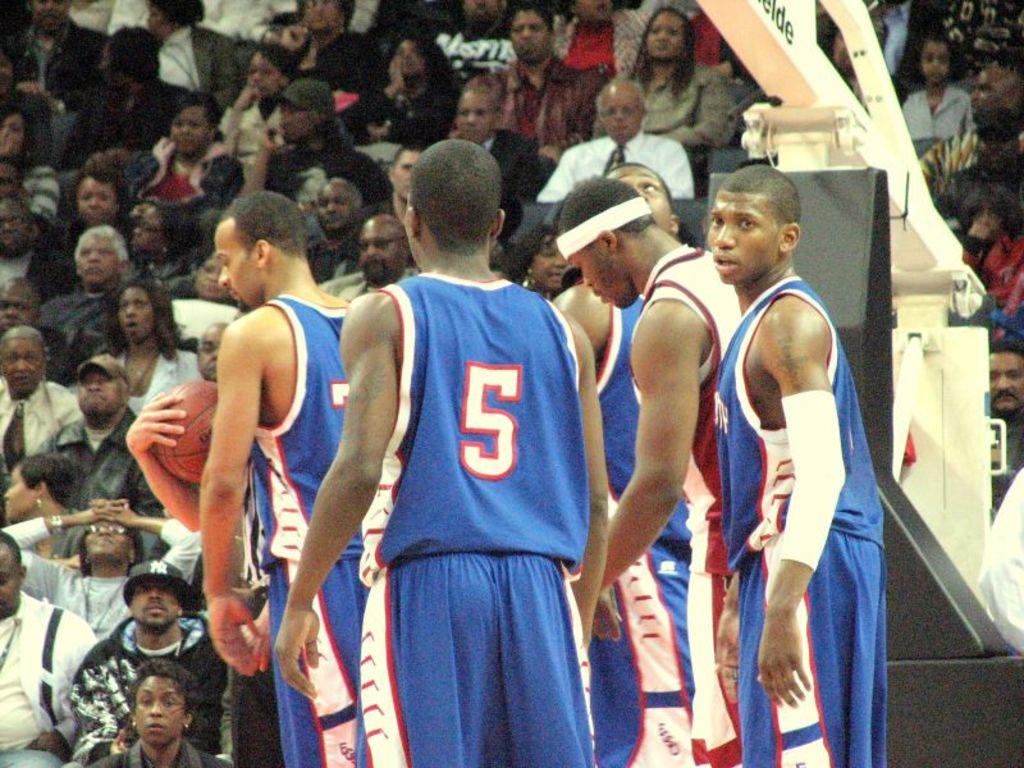<image>
Provide a brief description of the given image. A basketball player in a number 5 uniform stands near his teammates on the court. 